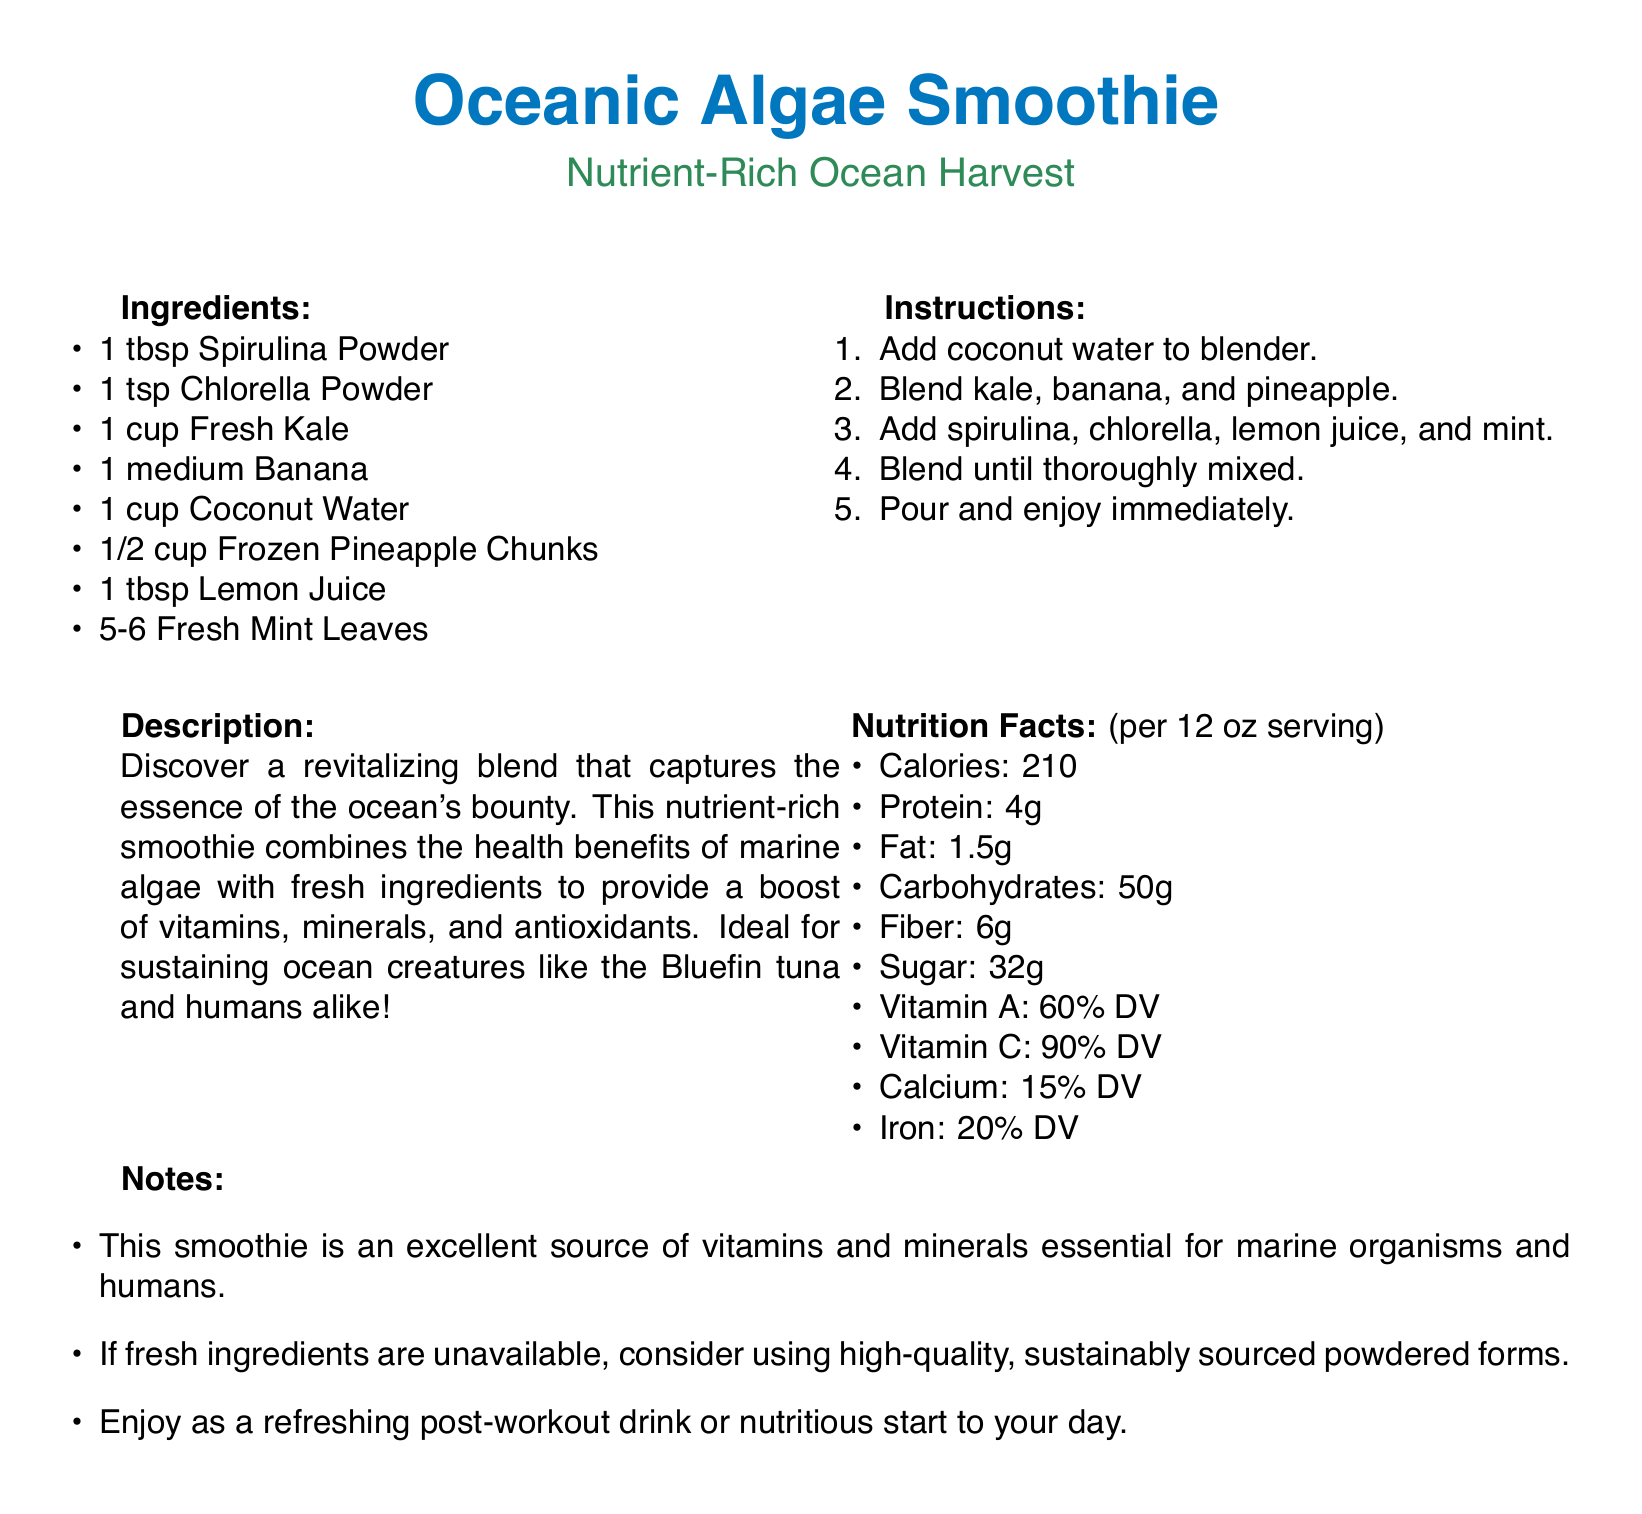What are the key ingredients in the Oceanic Algae Smoothie? The ingredients are listed clearly in the document, including spirulina powder and coconut water among others.
Answer: Spirulina Powder, Chlorella Powder, Fresh Kale, Banana, Coconut Water, Frozen Pineapple Chunks, Lemon Juice, Fresh Mint Leaves How many calories does the smoothie contain per serving? The nutrition facts section explicitly states the number of calories per serving.
Answer: 210 What type of vitamins does the smoothie provide? The nutrition facts mention Vitamin A and Vitamin C among others as essential nutrients.
Answer: Vitamin A, Vitamin C What is the recommended use for this smoothie? The notes section suggests consuming the smoothie as a post-workout drink or nutritious start to the day.
Answer: Refreshing post-workout drink, nutritious start to day What is the serving size of the Oceanic Algae Smoothie? The document specifies the serving size in the nutrition facts section which mentions the amount directly.
Answer: 12 oz What is the primary color theme used in the document? The header colors and text emphasize sea-related hues like ocean blue and sea green.
Answer: Ocean blue, seagreen 